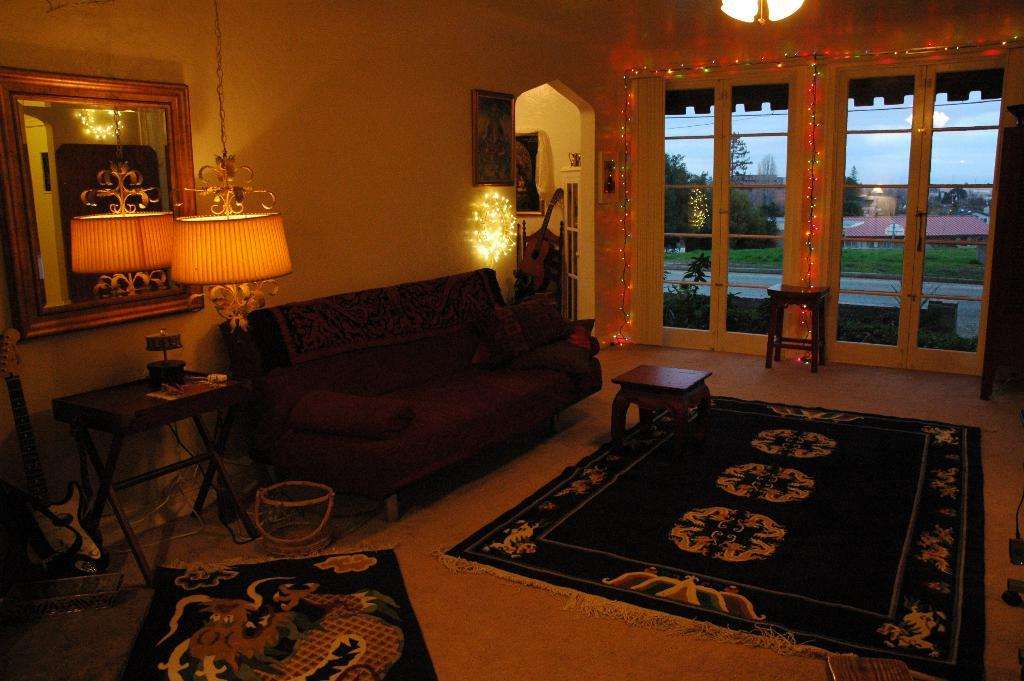What type of lighting is present in the room? There is a lamp light in the room. What type of seating is available in the room? There is a couch and a stool in the room. What type of floor covering is present in the room? There is a mat in the room. What is the color of the wall in the room? The wall in the room is white. Is there a source of natural light in the room? Yes, there is a window in the room. What type of fuel is used to power the lamp light in the image? The lamp light in the image does not require fuel to function; it is likely powered by electricity. What type of frame is present around the window in the image? There is no mention of a frame around the window in the image; only the window itself is described. 